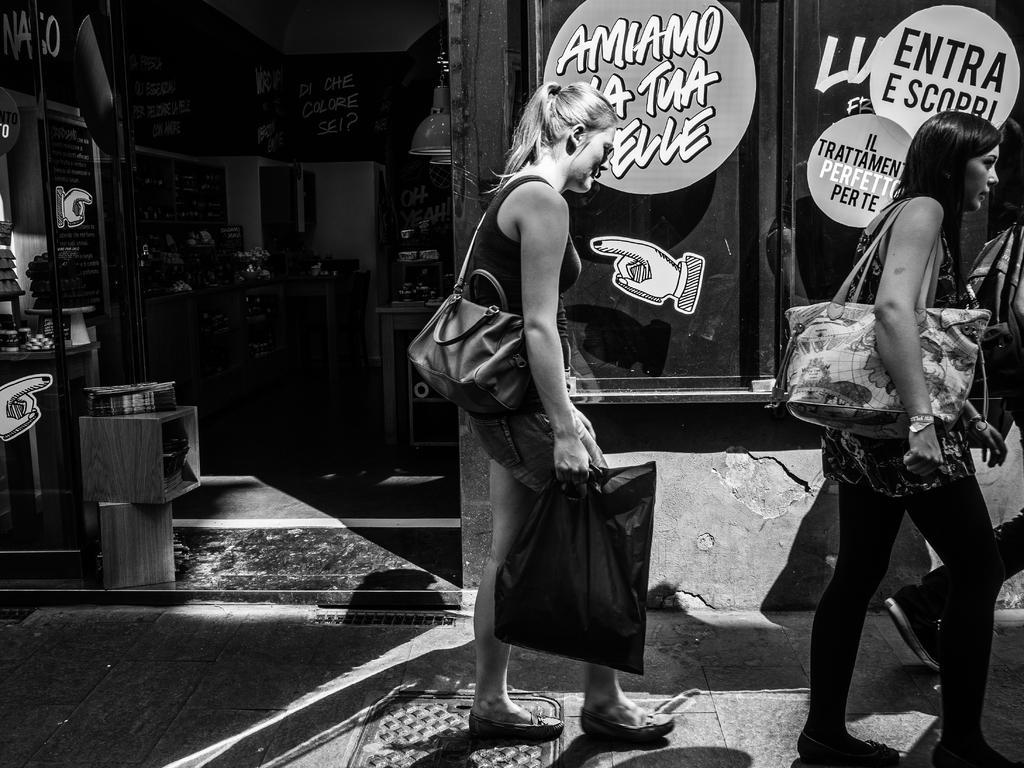In one or two sentences, can you explain what this image depicts? This picture is taken outside before a store. The picture is in black and white. In the center there is a woman, she is wearing a bag and holding a cover. Towards the right there is another woman, she is carrying a bag. Behind them there is a wall with some text and pictures printed on it. 